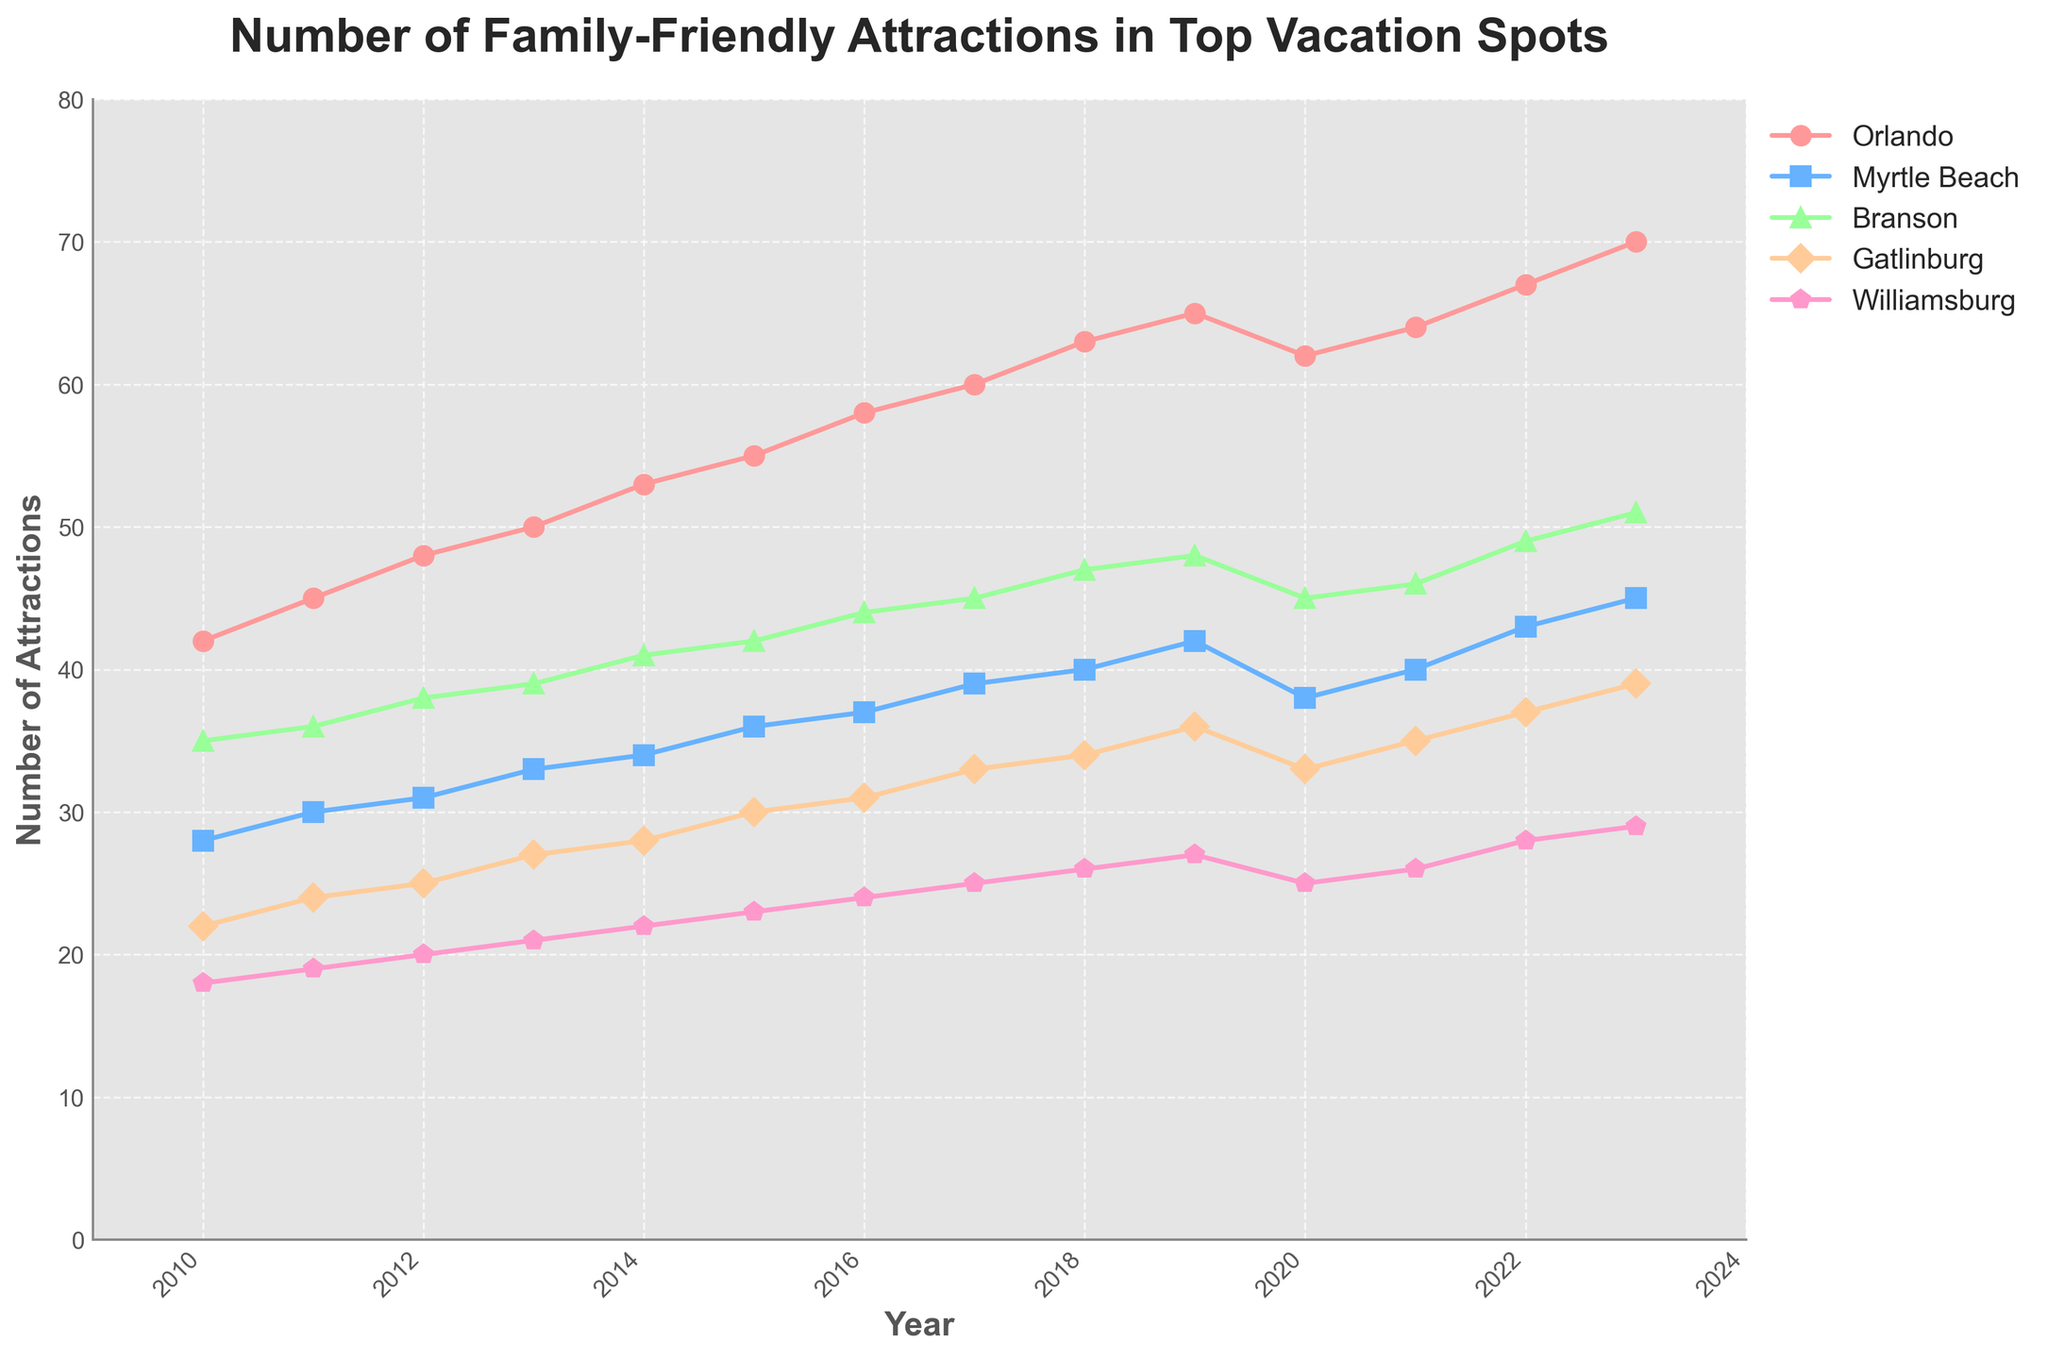What's the trend for family-friendly attractions in Orlando over the years? By looking at the line representing Orlando, it shows a steady increase from 42 attractions in 2010 to 70 in 2023. Even during 2020, the dip is minimal, followed by a recovery.
Answer: Steady increase Which city had the most significant increase in family-friendly attractions from 2010 to 2023? To answer, we compare the differences for each city between 2010 and 2023: Orlando (70-42 = 28), Myrtle Beach (45-28 = 17), Branson (51-35 = 16), Gatlinburg (39-22 = 17), Williamsburg (29-18 = 11). Orlando has the highest increase with 28 attractions.
Answer: Orlando In 2020, did any city experience a drop in family-friendly attractions compared to 2019, and if so, which ones? From the figure, compare the values of 2019 and 2020. Orlando dropped from 65 to 62, Branson from 48 to 45, Gatlinburg from 36 to 33, and Williamsburg from 27 to 25, showing a decrease in these cities. Myrtle Beach shows no decrease as it went from 42 to 38.
Answer: Orlando, Branson, Gatlinburg, Williamsburg On average, how many family-friendly attractions did Gatlinburg have per year from 2010 to 2023? To find the average, sum all annual values for Gatlinburg from 2010 (22) to 2023 (39) and divide by the number of years: (22+24+25+27+28+30+31+33+34+36+33+35+37+39)/14 = 429/14 = 30.64.
Answer: 30.64 How does the number of attractions in Myrtle Beach in 2023 compare to those in Williamsburg? From the figure, Myrtle Beach has 45 attractions in 2023 while Williamsburg has 29. Myrtle Beach has more attractions compared to Williamsburg.
Answer: Myrtle Beach has more What was the overall trend for family-friendly attractions in Branson from 2010 to 2023? The line for Branson shows an upward trend from 35 in 2010 to 51 in 2023, indicating a steady increase over the years, despite a slight drop in 2020.
Answer: Steady increase Which year did Williamsburg see a noticeable bump in the number of attractions? Observing the figure, Williamsburg saw a noticeable increase between 2015 to 2016 from 23 to 24, but also consistently increased annually in smaller increments. The bump is part of a steady increase pattern.
Answer: Steady increase around 2016 In terms of family-friendly attractions, which city had the least growth from 2010 to 2023? Calculating the difference for each city, Williamsburg had the smallest increase: (29-18 = 11), which is lower than all other cities' increases.
Answer: Williamsburg If a family visited Branson every two years starting from 2010, what is the total number of attractions they would have seen by 2022? Adding the number of attractions biennially: 2010 (35) + 2012 (38) + 2014 (41) + 2016 (44) + 2018 (47) + 2020 (45) + 2022 (49) = 299.
Answer: 299 